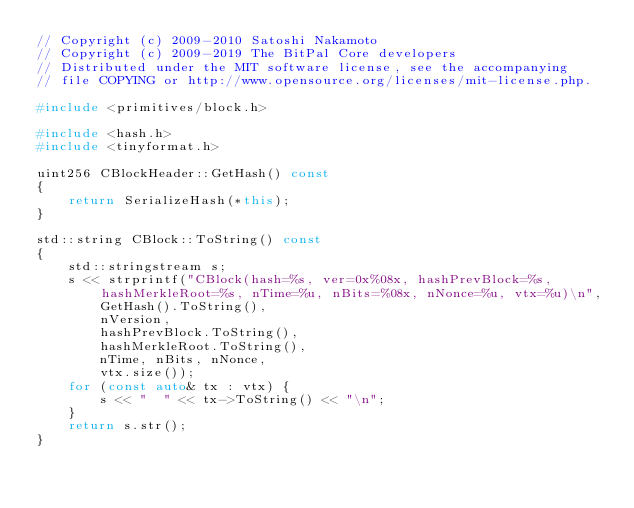Convert code to text. <code><loc_0><loc_0><loc_500><loc_500><_C++_>// Copyright (c) 2009-2010 Satoshi Nakamoto
// Copyright (c) 2009-2019 The BitPal Core developers
// Distributed under the MIT software license, see the accompanying
// file COPYING or http://www.opensource.org/licenses/mit-license.php.

#include <primitives/block.h>

#include <hash.h>
#include <tinyformat.h>

uint256 CBlockHeader::GetHash() const
{
    return SerializeHash(*this);
}

std::string CBlock::ToString() const
{
    std::stringstream s;
    s << strprintf("CBlock(hash=%s, ver=0x%08x, hashPrevBlock=%s, hashMerkleRoot=%s, nTime=%u, nBits=%08x, nNonce=%u, vtx=%u)\n",
        GetHash().ToString(),
        nVersion,
        hashPrevBlock.ToString(),
        hashMerkleRoot.ToString(),
        nTime, nBits, nNonce,
        vtx.size());
    for (const auto& tx : vtx) {
        s << "  " << tx->ToString() << "\n";
    }
    return s.str();
}
</code> 